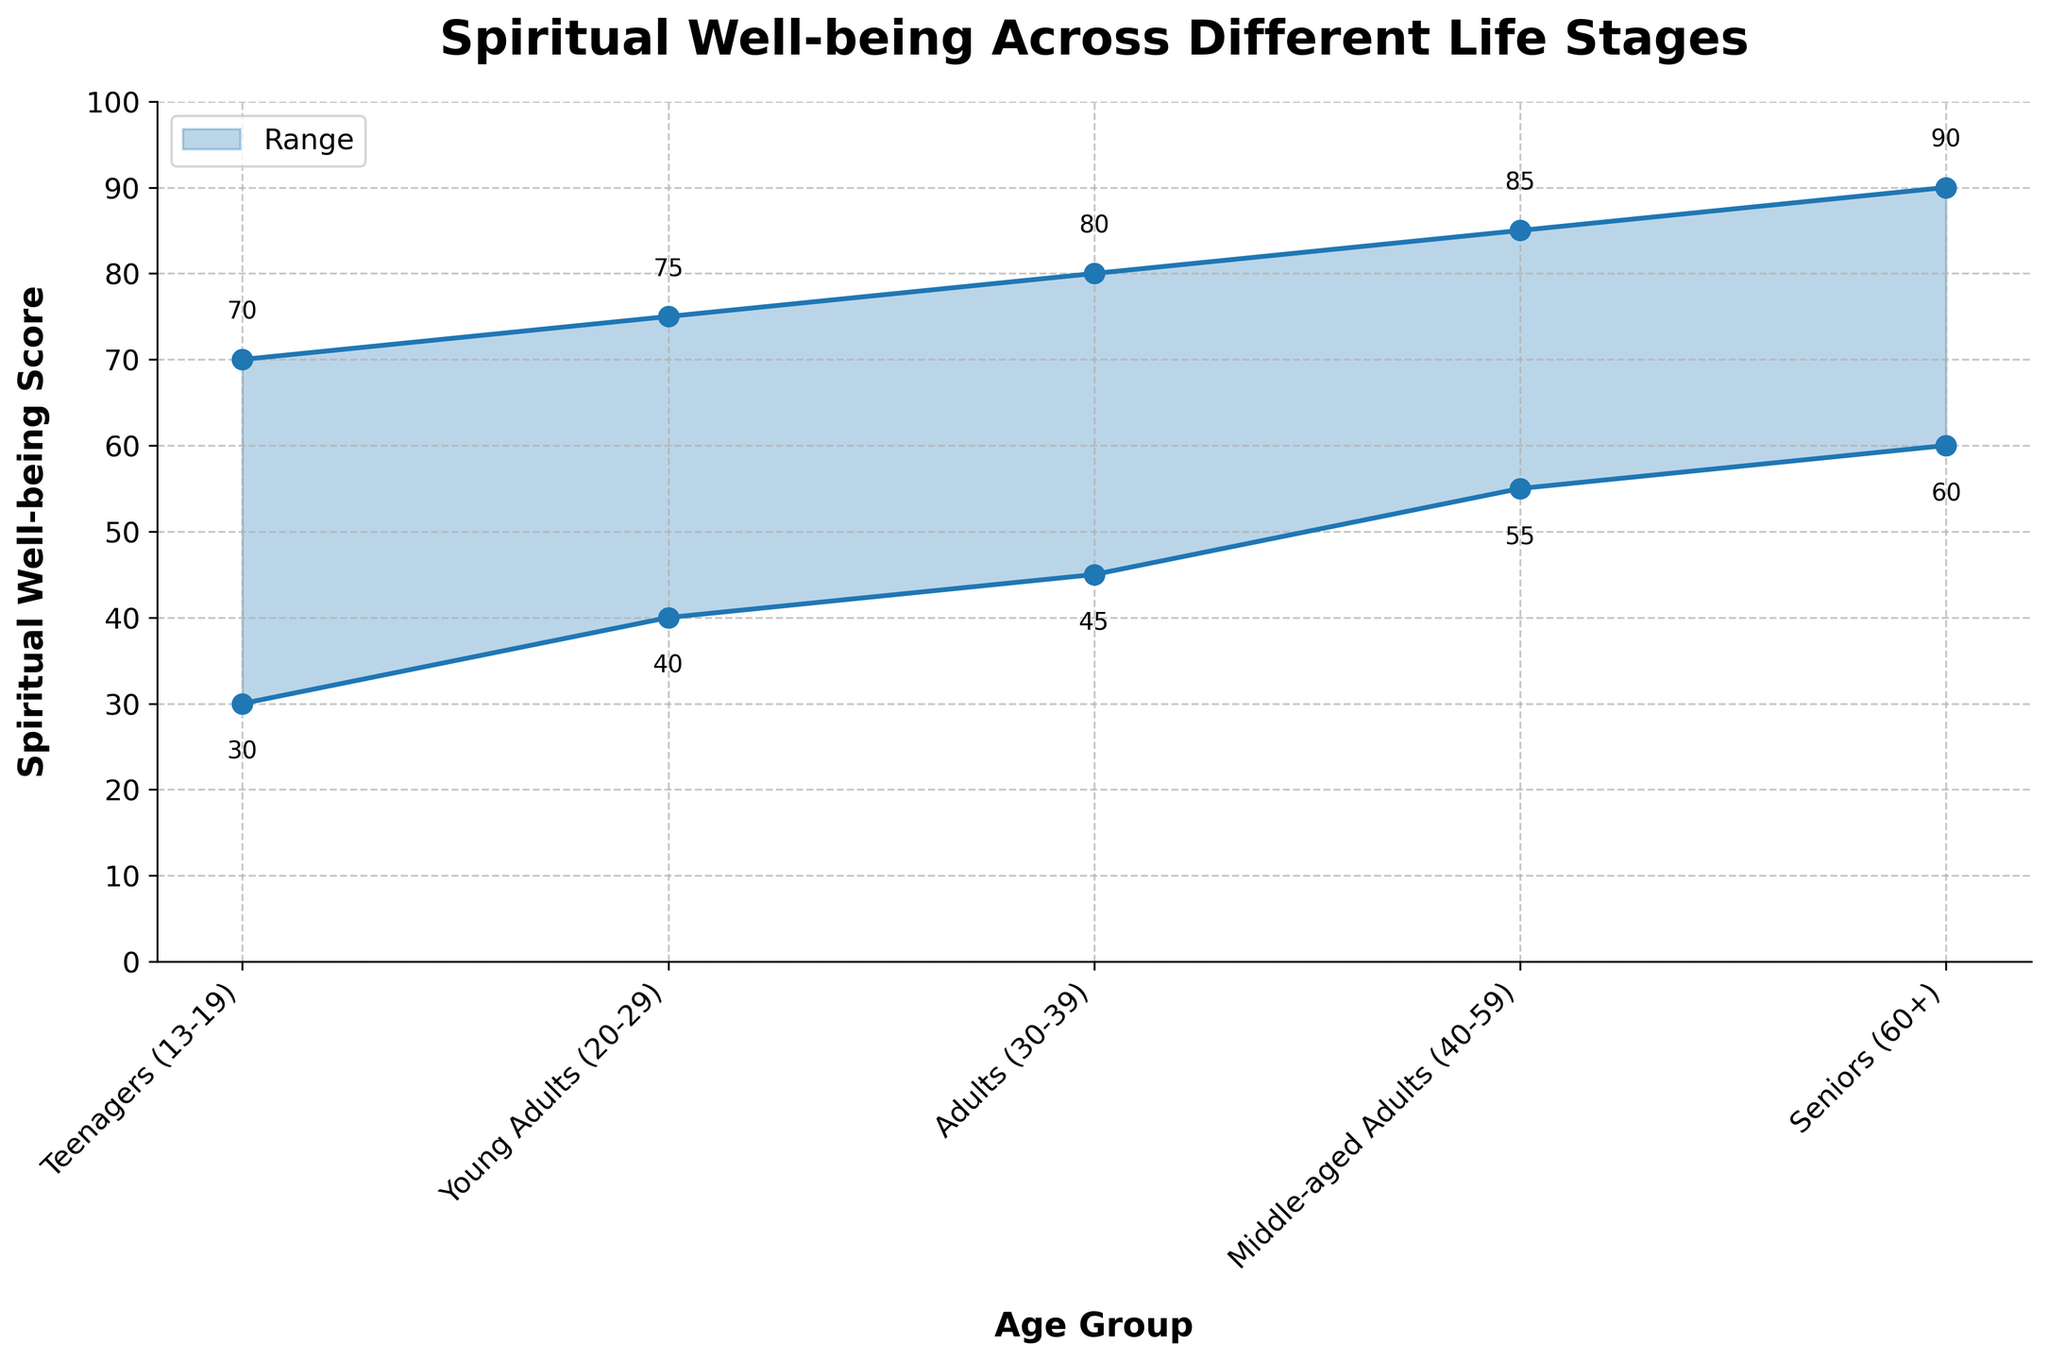What is the title of the chart? The title of the chart is prominently displayed at the top in bold. It reads: "Spiritual Well-being Across Different Life Stages".
Answer: Spiritual Well-being Across Different Life Stages Which age group has the highest maximum spiritual well-being score? Based on the plotted data, the age group with the highest maximum spiritual well-being score is marked at the top of the filled area. For Seniors (60+), this value is 90.
Answer: Seniors (60+) What is the difference between the minimum and maximum spiritual well-being scores for Young Adults (20-29)? For the Young Adults (20-29), the minimum score is 40 and the maximum is 75. The difference is calculated as 75 - 40.
Answer: 35 Which age group exhibits the smallest range of spiritual well-being scores? The range is computed as the difference between the maximum and minimum scores for each age group. The smallest range, by visual inspection, is for Teenagers (13-19) with values 70 - 30 = 40.
Answer: Teenagers (13-19) How does the minimum spiritual well-being score of Middle-aged Adults (40-59) compare to the maximum score of Teenagers (13-19)? By comparing the values directly from the chart, the minimum score for Middle-aged Adults (40-59) is 55, and the maximum score for Teenagers (13-19) is 70. 55 is less than 70.
Answer: Less than What is the overall trend in the maximum spiritual well-being score as age increases? Observing the plotted maximum values from Teenagers to Seniors, the scores show an increasing trend with the highest score at the Seniors (60+).
Answer: Increasing What is the average maximum spiritual well-being score across all age groups? The maximum values are 70, 75, 80, 85, and 90. Summing these gives 400, and dividing by 5 age groups, the average is 400 / 5.
Answer: 80 In which age group does the minimum spiritual well-being score exceed 50? Looking at the minimum value for each age group, Middle-aged Adults (40-59) and Seniors (60+) both have minimum scores greater than 50 (55 and 60, respectively).
Answer: Middle-aged Adults (40-59), Seniors (60+) Between which two consecutive age groups is the increase in minimum spiritual well-being the largest? Calculating the differences between consecutive minimum scores: Young Adults to Adults (5), Adults to Middle-aged Adults (10), Middle-aged Adults to Seniors (5). The largest increase is between Adults (30-39) and Middle-aged Adults (40-59).
Answer: Adults to Middle-aged Adults What color is used to represent the range area in the chart? The filled area representing the range is shaded in a color that appears as a shade of blue, specifically a darker blue tone.
Answer: Blue 